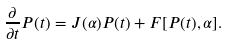Convert formula to latex. <formula><loc_0><loc_0><loc_500><loc_500>\frac { \partial } { \partial t } P ( t ) = J ( \alpha ) P ( t ) + F [ P ( t ) , \alpha ] .</formula> 